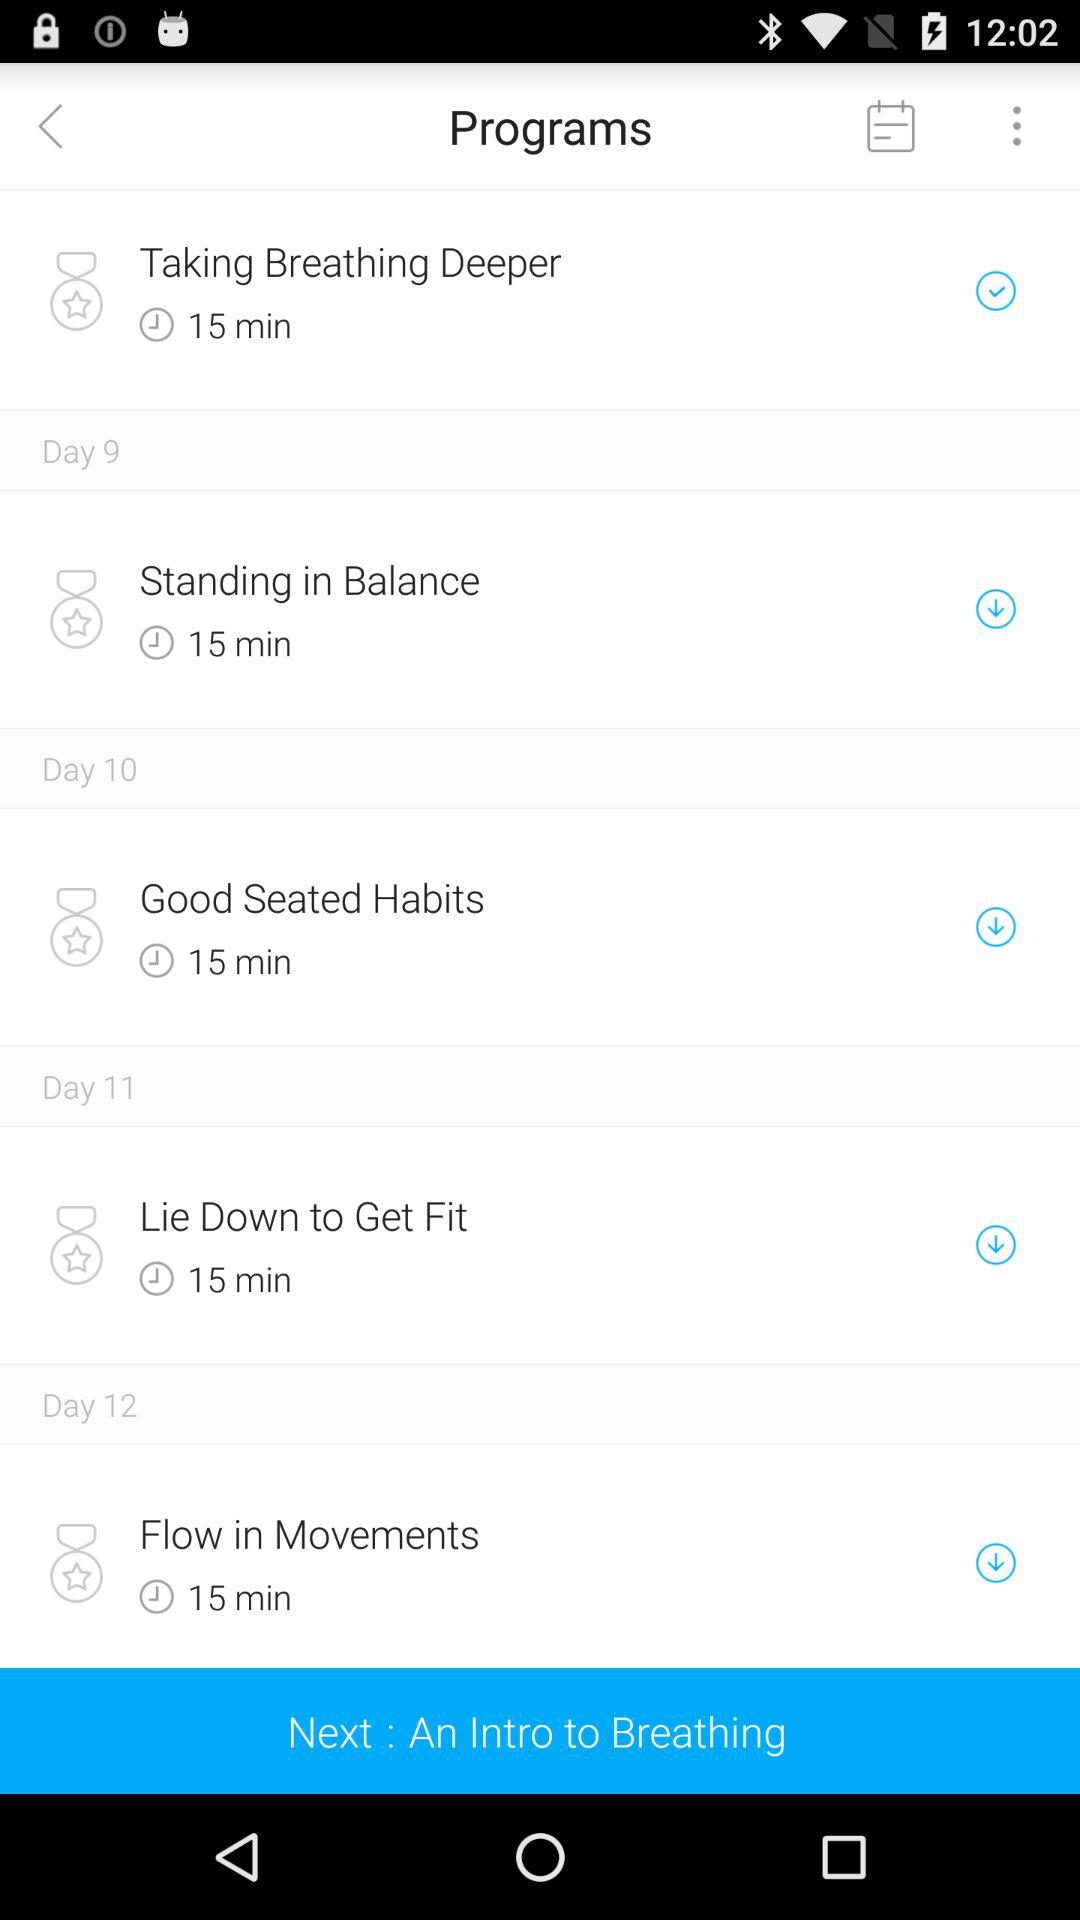What is the program on day 12? The program is "Flow in Movements". 